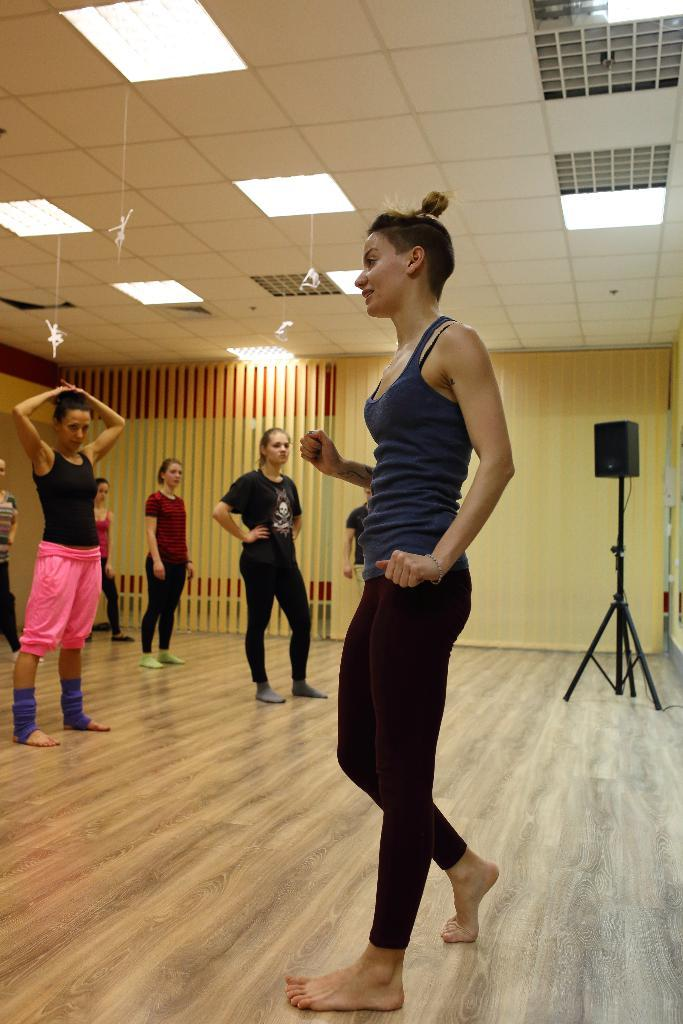What can be seen in the image regarding the people present? There are women standing in the image. What is the floor made of in the image? The floor is made of wood. Can you describe any objects on the floor in the image? There is a speaker on the floor on the right side. What can be seen on the roof in the image? There is a lighting arrangement on the roof. What type of van is parked outside the building in the image? There is no van present in the image; it only shows the interior with women, a wooden floor, a speaker, and a lighting arrangement on the roof. 